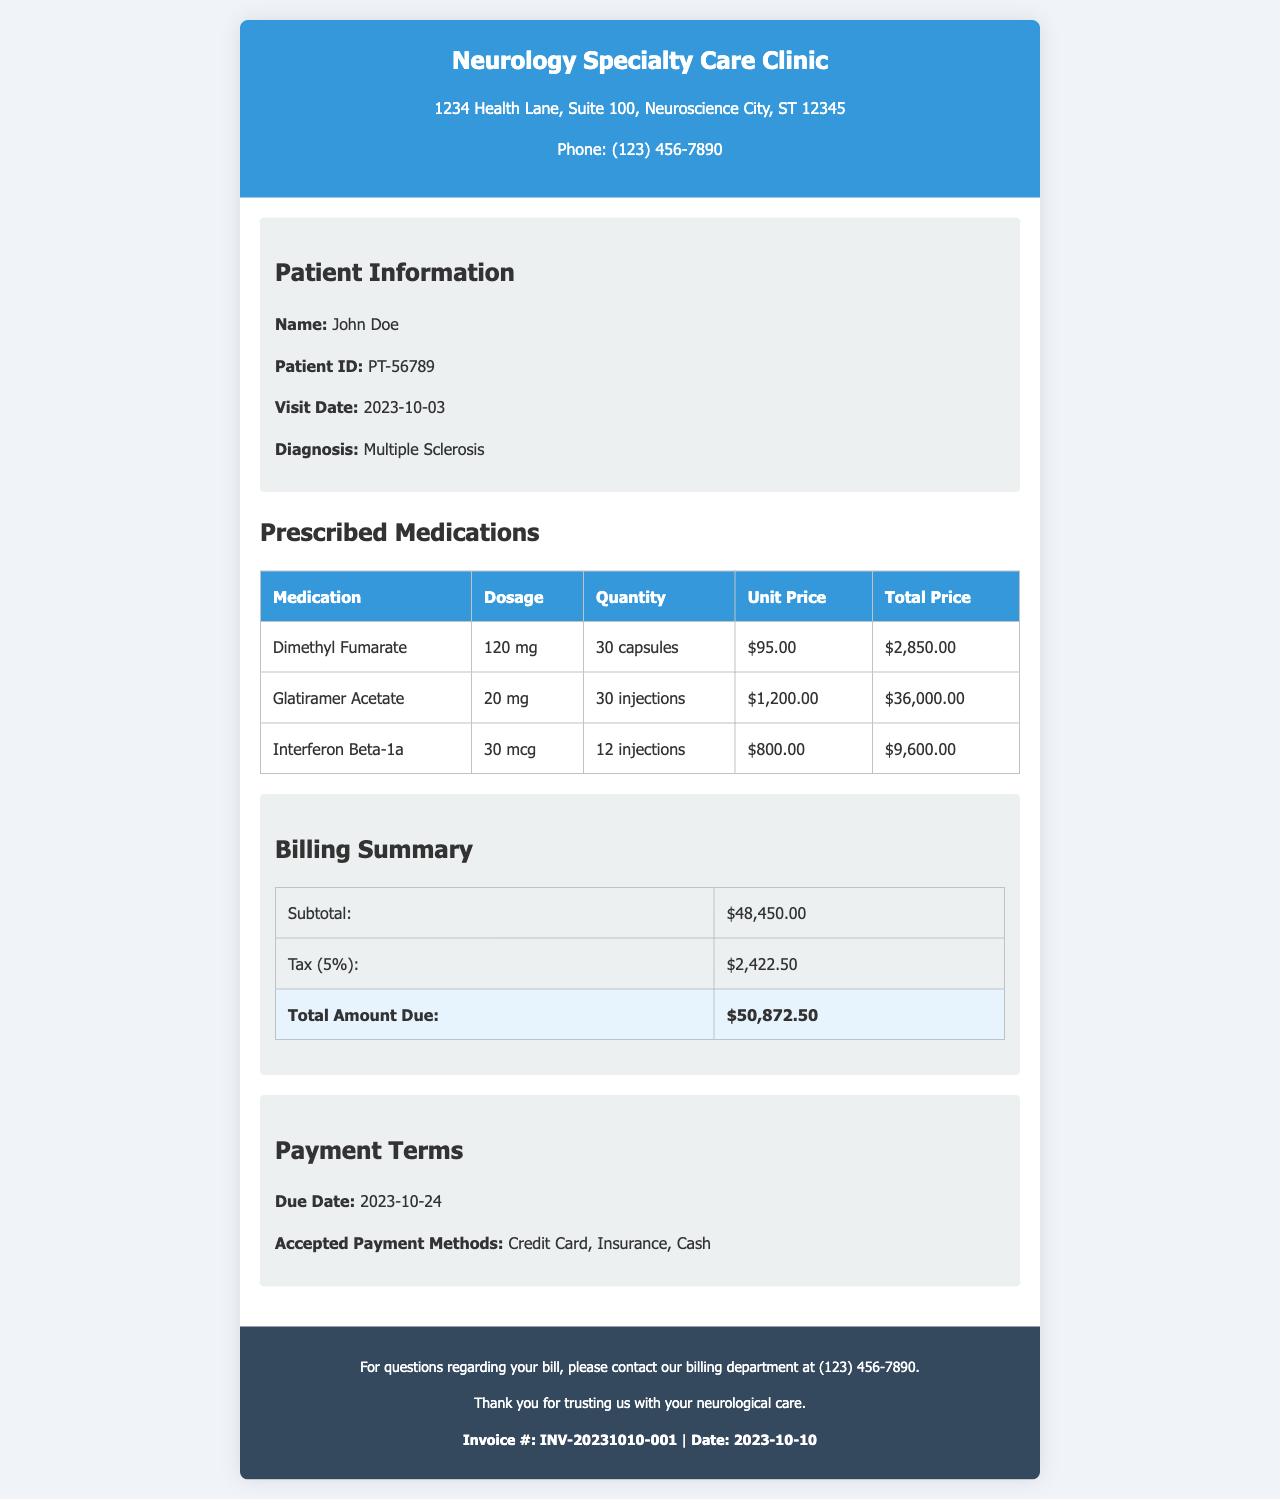What is the total amount due? The total amount due is listed in the billing summary section of the document, which shows $50,872.50.
Answer: $50,872.50 What is the patient's diagnosis? The patient's diagnosis is mentioned in the patient information section as Multiple Sclerosis.
Answer: Multiple Sclerosis How many capsules of Dimethyl Fumarate were prescribed? The quantity of Dimethyl Fumarate is stated in the prescribed medications table as 30 capsules.
Answer: 30 capsules What is the tax rate applied to the subtotal? The tax rate is listed in the billing summary section as 5%.
Answer: 5% What is the due date for the payment? The due date is provided in the payment terms section as October 24, 2023.
Answer: 2023-10-24 How much does one injection of Glatiramer Acetate cost? The unit price for one injection of Glatiramer Acetate is given in the prescribed medications table as $1,200.00.
Answer: $1,200.00 Which medication has the highest total price? The highest total price is derived from the prescribed medications table, where Glatiramer Acetate totals $36,000.00.
Answer: Glatiramer Acetate What is the total price for Interferon Beta-1a? The total price for Interferon Beta-1a is shown in the prescribed medications table as $9,600.00.
Answer: $9,600.00 